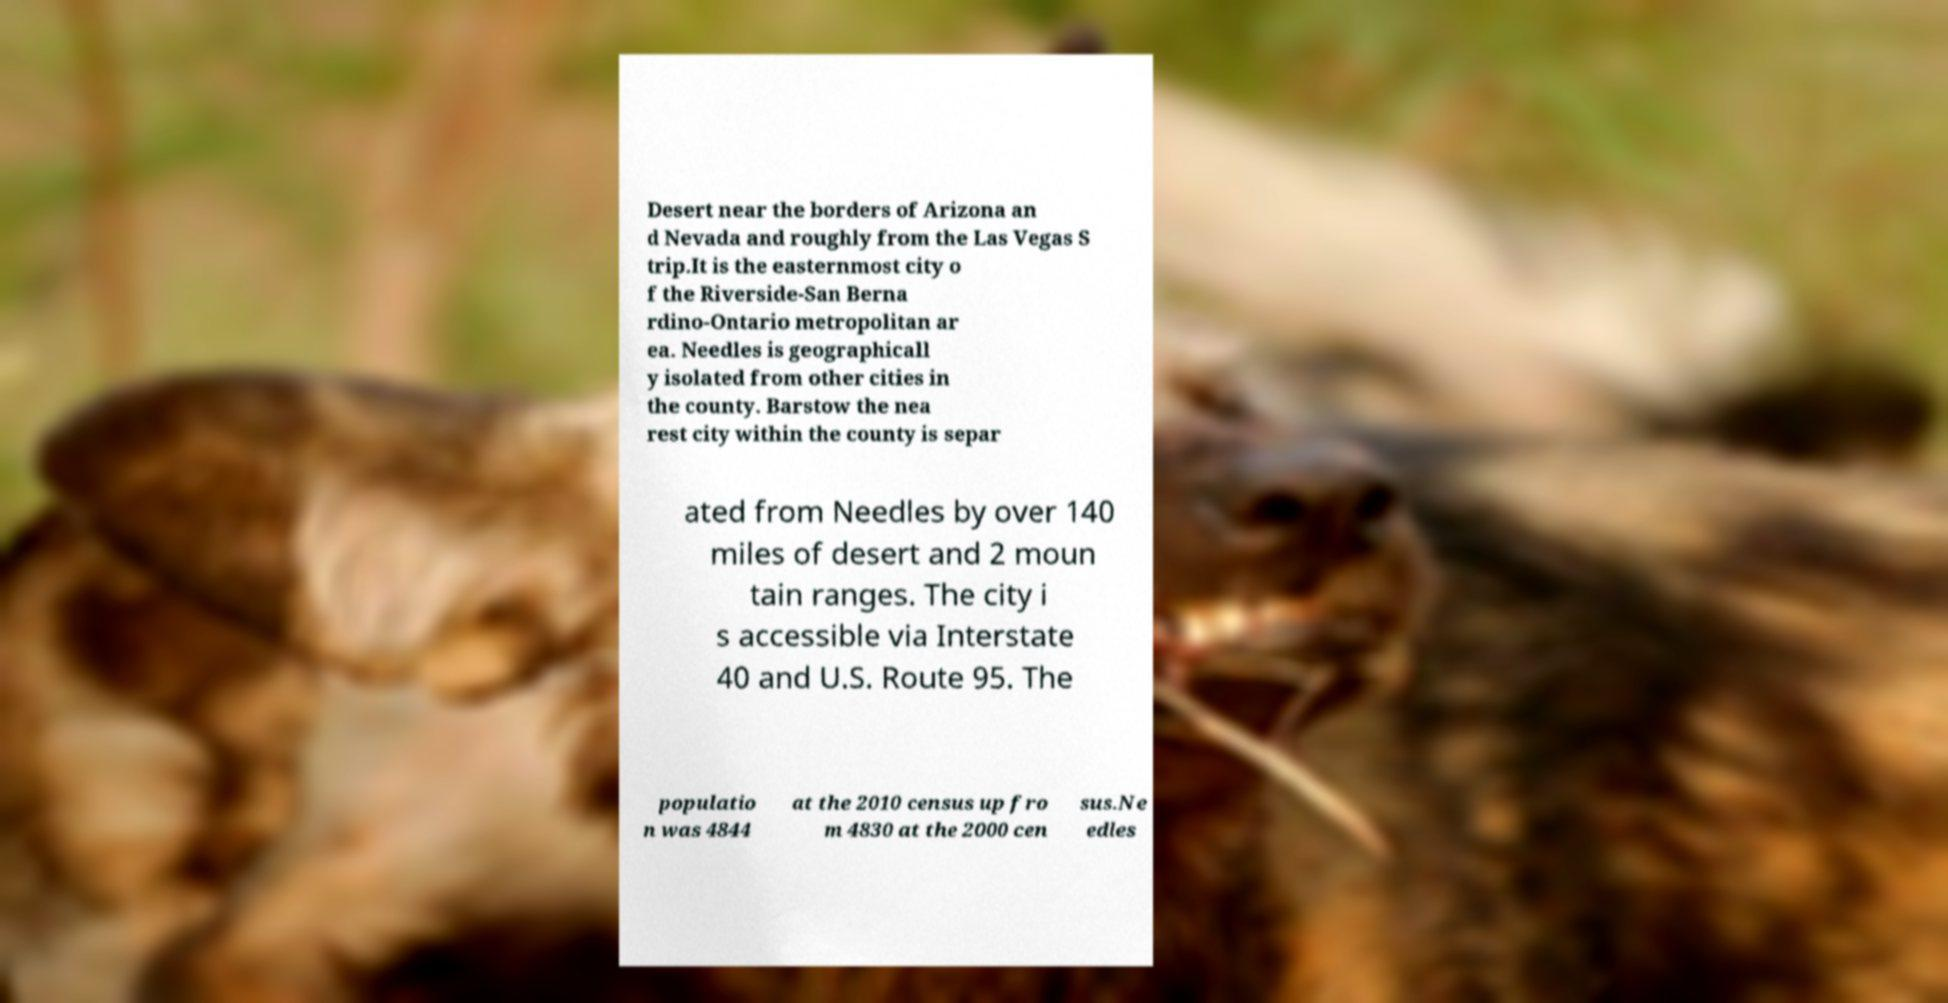Could you extract and type out the text from this image? Desert near the borders of Arizona an d Nevada and roughly from the Las Vegas S trip.It is the easternmost city o f the Riverside-San Berna rdino-Ontario metropolitan ar ea. Needles is geographicall y isolated from other cities in the county. Barstow the nea rest city within the county is separ ated from Needles by over 140 miles of desert and 2 moun tain ranges. The city i s accessible via Interstate 40 and U.S. Route 95. The populatio n was 4844 at the 2010 census up fro m 4830 at the 2000 cen sus.Ne edles 